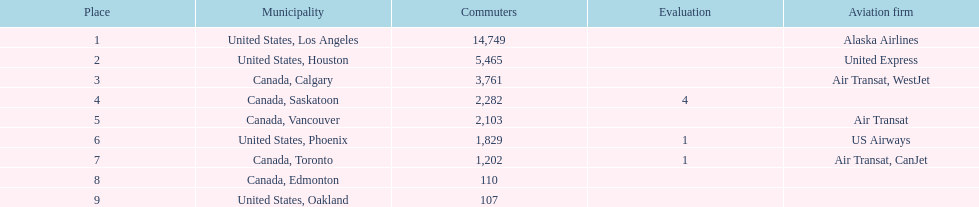Which canadian city had the most passengers traveling from manzanillo international airport in 2013? Calgary. 